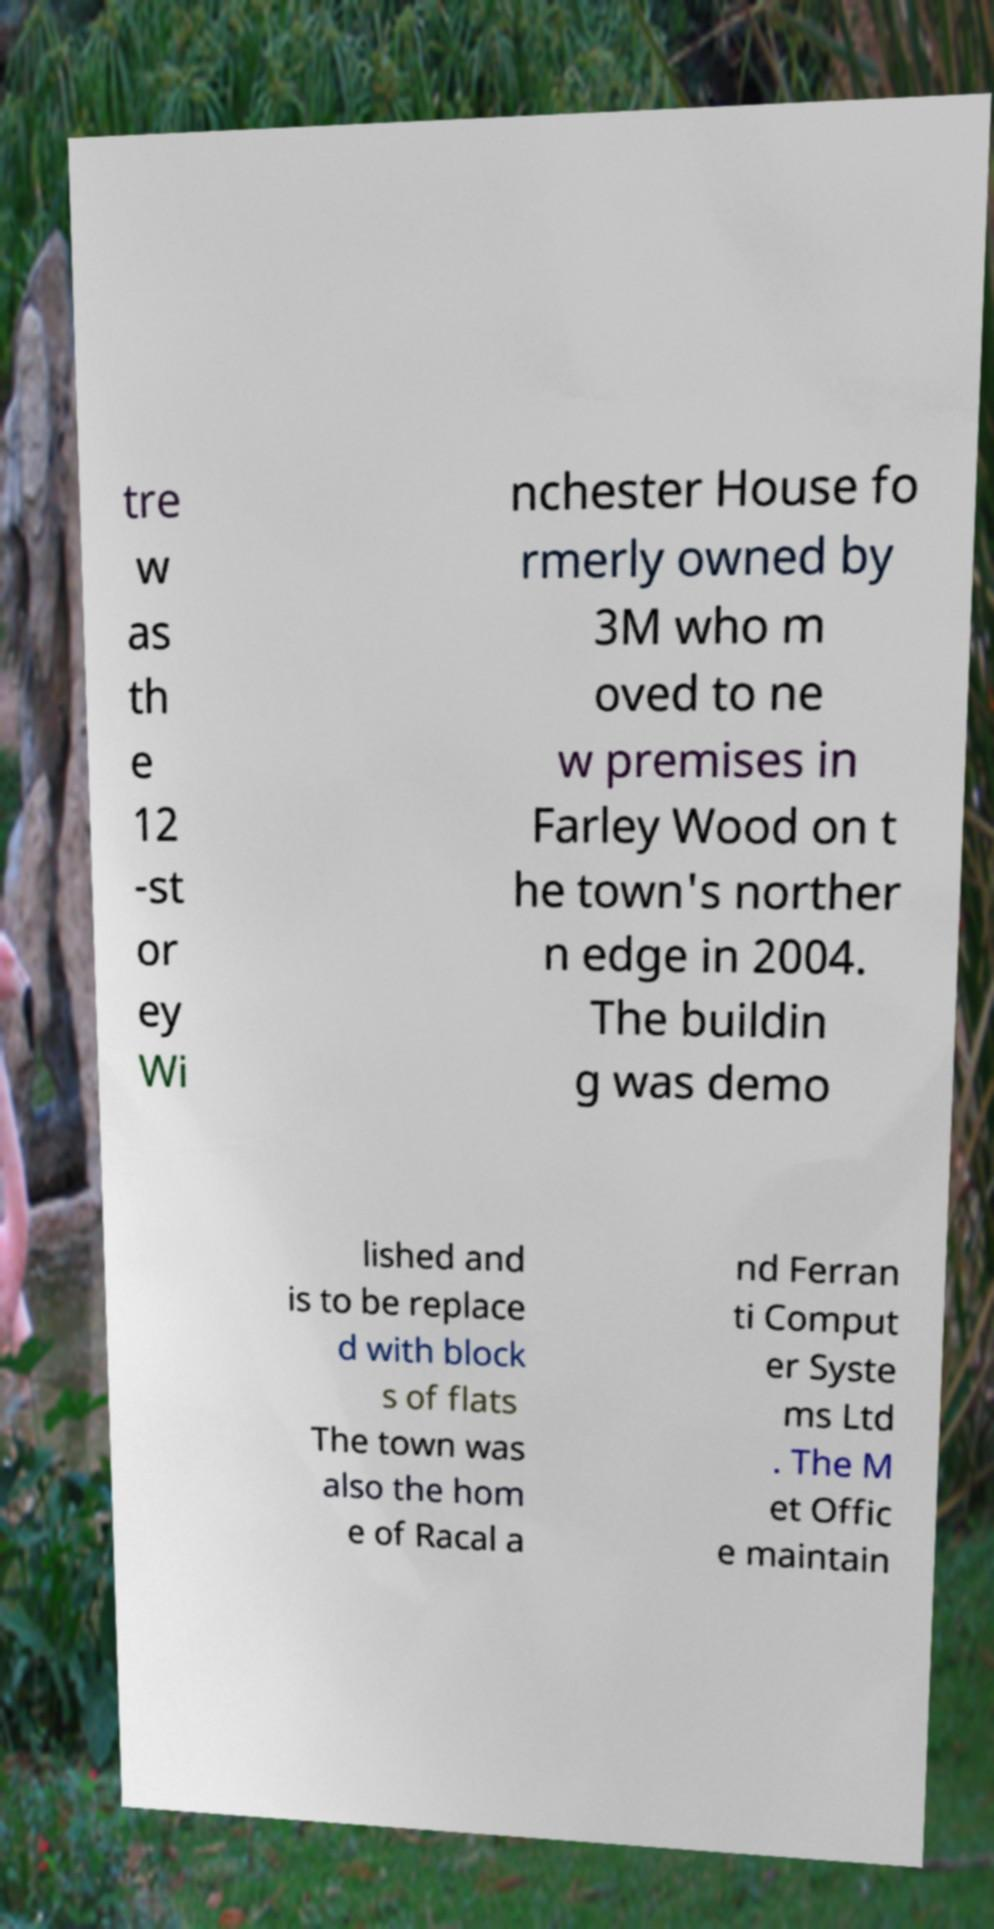What messages or text are displayed in this image? I need them in a readable, typed format. tre w as th e 12 -st or ey Wi nchester House fo rmerly owned by 3M who m oved to ne w premises in Farley Wood on t he town's norther n edge in 2004. The buildin g was demo lished and is to be replace d with block s of flats The town was also the hom e of Racal a nd Ferran ti Comput er Syste ms Ltd . The M et Offic e maintain 